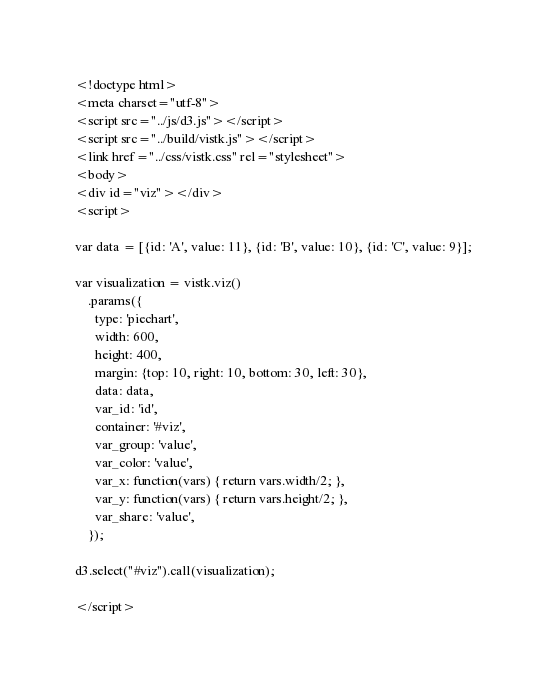<code> <loc_0><loc_0><loc_500><loc_500><_HTML_><!doctype html>
<meta charset="utf-8">
<script src="../js/d3.js"></script>
<script src="../build/vistk.js"></script>
<link href="../css/vistk.css" rel="stylesheet">
<body>
<div id="viz"></div>
<script>

var data = [{id: 'A', value: 11}, {id: 'B', value: 10}, {id: 'C', value: 9}];

var visualization = vistk.viz()
    .params({
      type: 'piechart',
      width: 600,
      height: 400,
      margin: {top: 10, right: 10, bottom: 30, left: 30},
      data: data,
      var_id: 'id',
      container: '#viz',
      var_group: 'value',
      var_color: 'value',
      var_x: function(vars) { return vars.width/2; },
      var_y: function(vars) { return vars.height/2; },
      var_share: 'value',
    });

d3.select("#viz").call(visualization);

</script>
</code> 